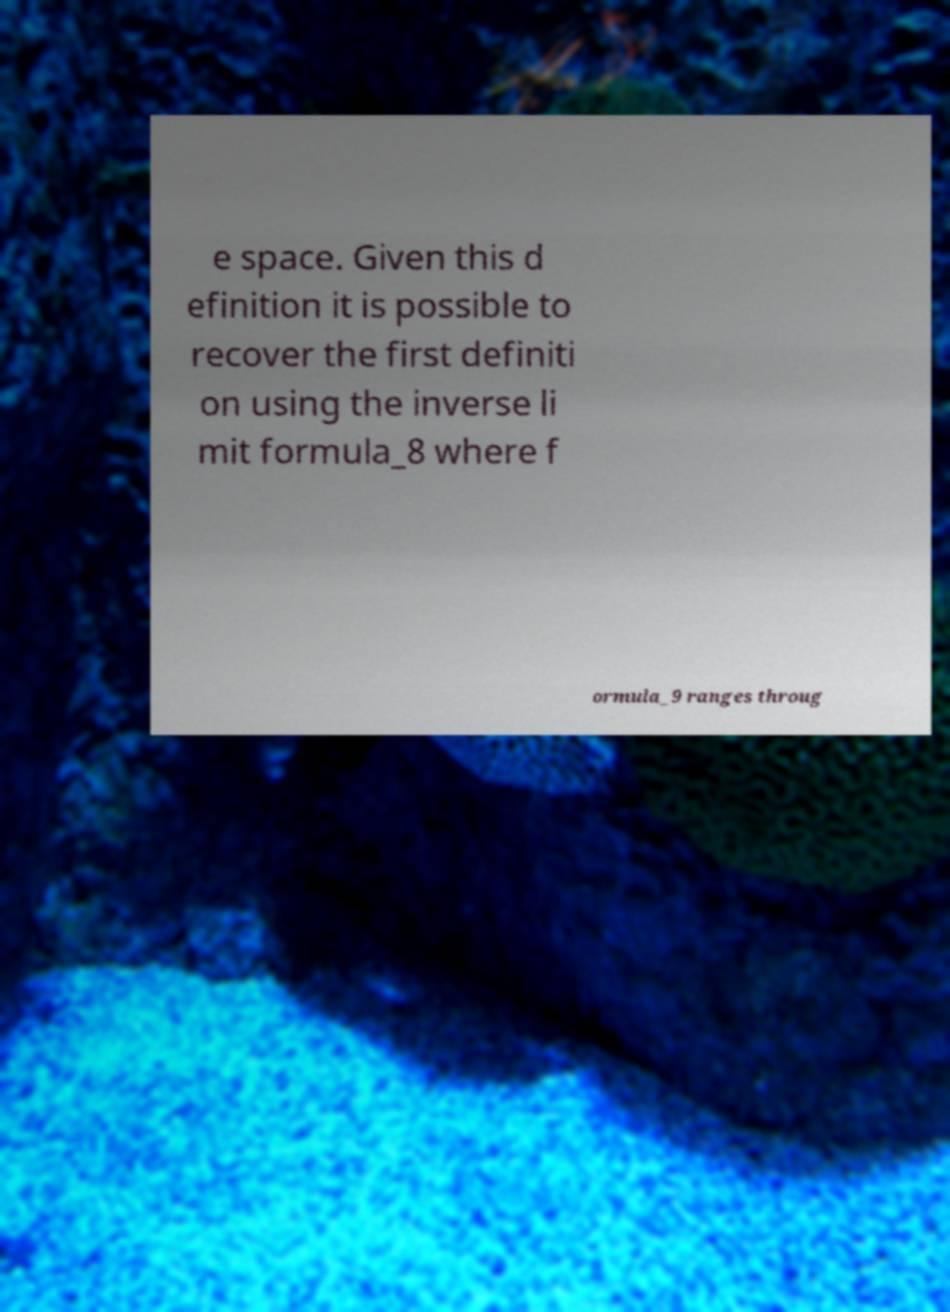I need the written content from this picture converted into text. Can you do that? e space. Given this d efinition it is possible to recover the first definiti on using the inverse li mit formula_8 where f ormula_9 ranges throug 